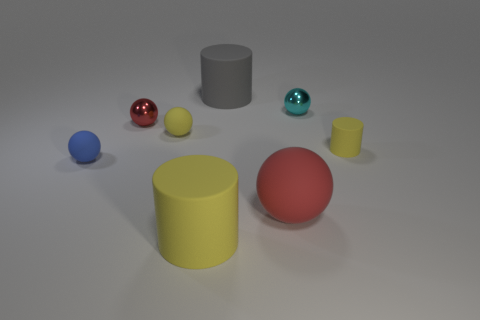Subtract all yellow spheres. How many spheres are left? 4 Subtract all blue spheres. How many spheres are left? 4 Subtract all blue spheres. Subtract all brown blocks. How many spheres are left? 4 Add 2 large things. How many objects exist? 10 Subtract all cylinders. How many objects are left? 5 Add 1 yellow cylinders. How many yellow cylinders exist? 3 Subtract 0 purple blocks. How many objects are left? 8 Subtract all small blue things. Subtract all blue rubber spheres. How many objects are left? 6 Add 6 big gray objects. How many big gray objects are left? 7 